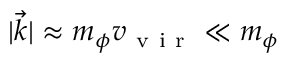Convert formula to latex. <formula><loc_0><loc_0><loc_500><loc_500>| \vec { k } | \approx m _ { \phi } v _ { v i r } \ll m _ { \phi }</formula> 